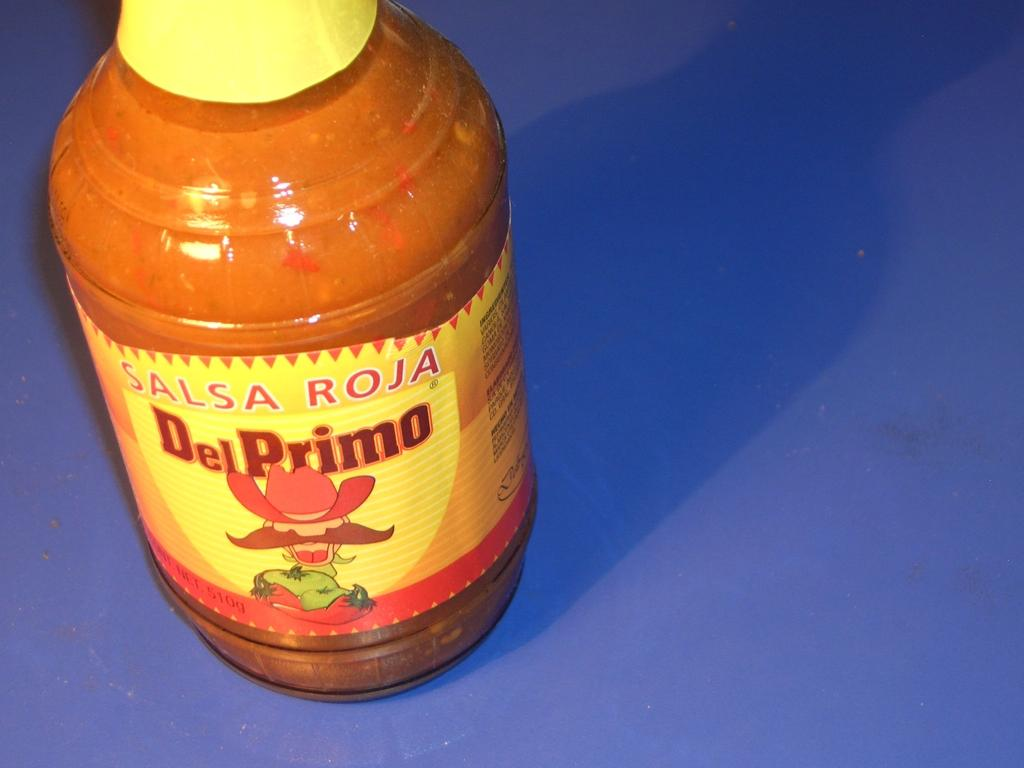What object can be seen in the image? There is a bottle in the image. What feature does the bottle have? The bottle has a label. What information is present on the label? The label contains text. What appliance is being used by the expert in the image? There is no appliance or expert present in the image; it only features a bottle with a labeled text. 